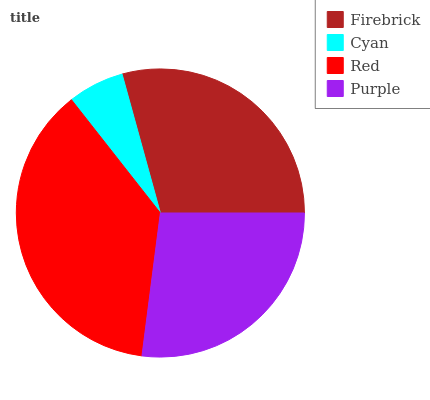Is Cyan the minimum?
Answer yes or no. Yes. Is Red the maximum?
Answer yes or no. Yes. Is Red the minimum?
Answer yes or no. No. Is Cyan the maximum?
Answer yes or no. No. Is Red greater than Cyan?
Answer yes or no. Yes. Is Cyan less than Red?
Answer yes or no. Yes. Is Cyan greater than Red?
Answer yes or no. No. Is Red less than Cyan?
Answer yes or no. No. Is Firebrick the high median?
Answer yes or no. Yes. Is Purple the low median?
Answer yes or no. Yes. Is Cyan the high median?
Answer yes or no. No. Is Cyan the low median?
Answer yes or no. No. 